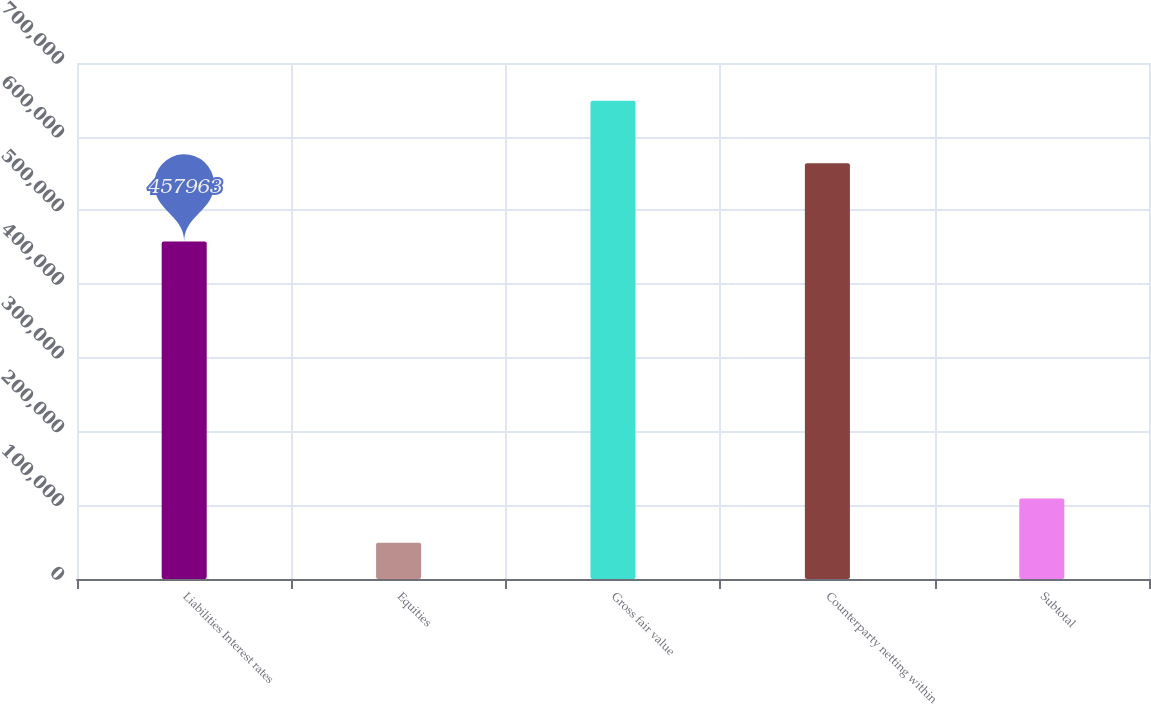Convert chart to OTSL. <chart><loc_0><loc_0><loc_500><loc_500><bar_chart><fcel>Liabilities Interest rates<fcel>Equities<fcel>Gross fair value<fcel>Counterparty netting within<fcel>Subtotal<nl><fcel>457963<fcel>49083<fcel>648905<fcel>564100<fcel>109065<nl></chart> 